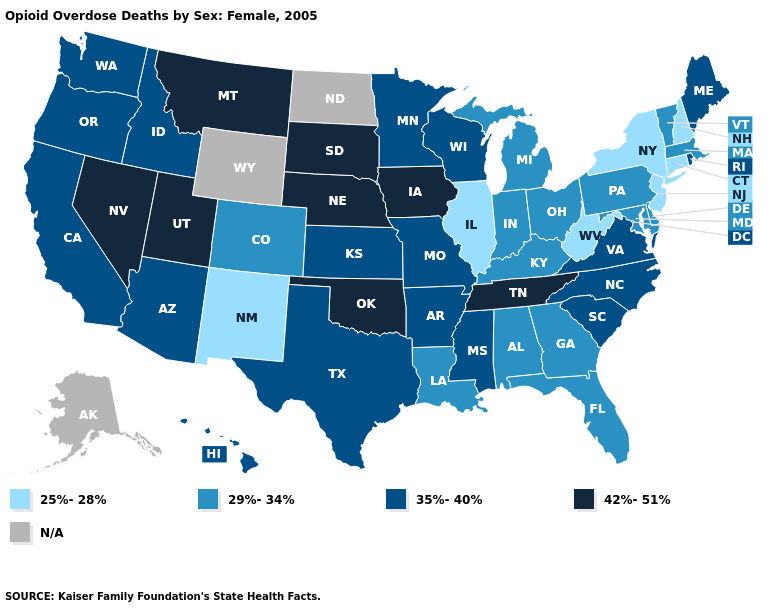Among the states that border Virginia , which have the lowest value?
Keep it brief. West Virginia. What is the lowest value in states that border Pennsylvania?
Concise answer only. 25%-28%. What is the value of Idaho?
Answer briefly. 35%-40%. Which states hav the highest value in the West?
Short answer required. Montana, Nevada, Utah. What is the value of Maine?
Answer briefly. 35%-40%. Does Rhode Island have the lowest value in the Northeast?
Answer briefly. No. Is the legend a continuous bar?
Give a very brief answer. No. Name the states that have a value in the range 29%-34%?
Write a very short answer. Alabama, Colorado, Delaware, Florida, Georgia, Indiana, Kentucky, Louisiana, Maryland, Massachusetts, Michigan, Ohio, Pennsylvania, Vermont. Does New Hampshire have the lowest value in the Northeast?
Quick response, please. Yes. Which states have the lowest value in the USA?
Keep it brief. Connecticut, Illinois, New Hampshire, New Jersey, New Mexico, New York, West Virginia. Among the states that border Utah , which have the lowest value?
Keep it brief. New Mexico. Name the states that have a value in the range 25%-28%?
Answer briefly. Connecticut, Illinois, New Hampshire, New Jersey, New Mexico, New York, West Virginia. What is the value of Georgia?
Answer briefly. 29%-34%. Does the map have missing data?
Be succinct. Yes. 